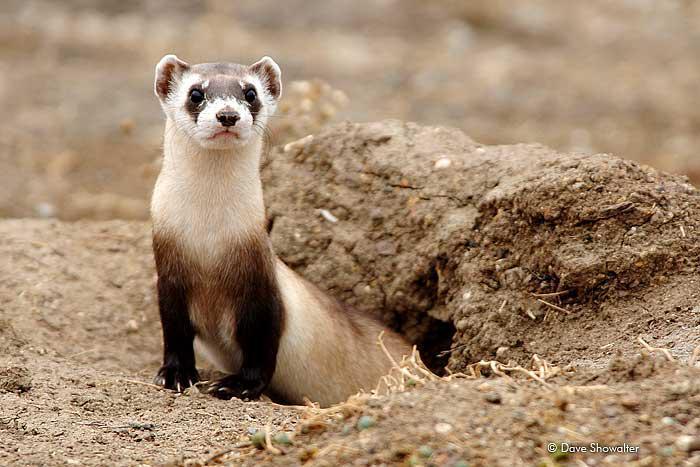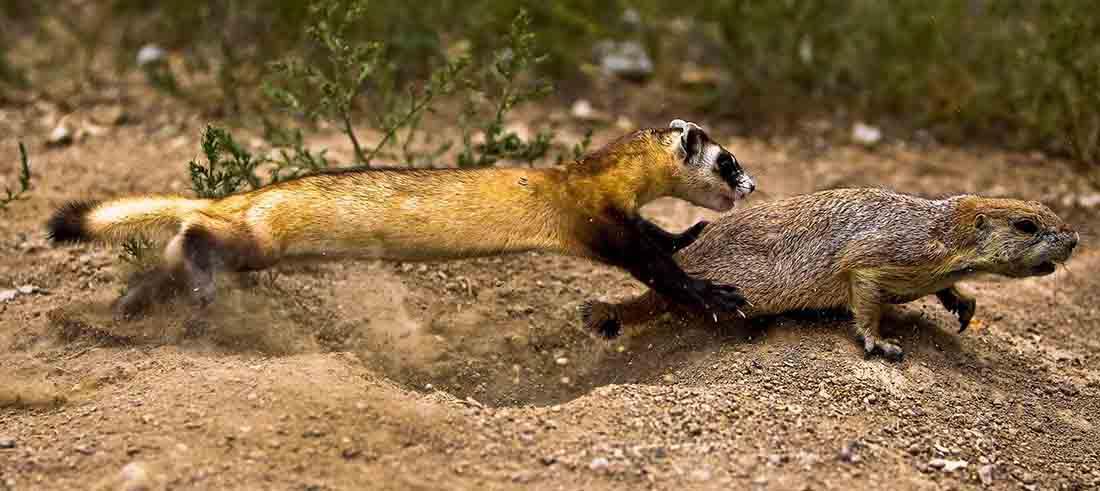The first image is the image on the left, the second image is the image on the right. Assess this claim about the two images: "The combined images include two ferrets in very similar poses, with heads turned the same direction, and all ferrets have raised heads.". Correct or not? Answer yes or no. No. The first image is the image on the left, the second image is the image on the right. Evaluate the accuracy of this statement regarding the images: "In one of the images there are 2 animals.". Is it true? Answer yes or no. Yes. 